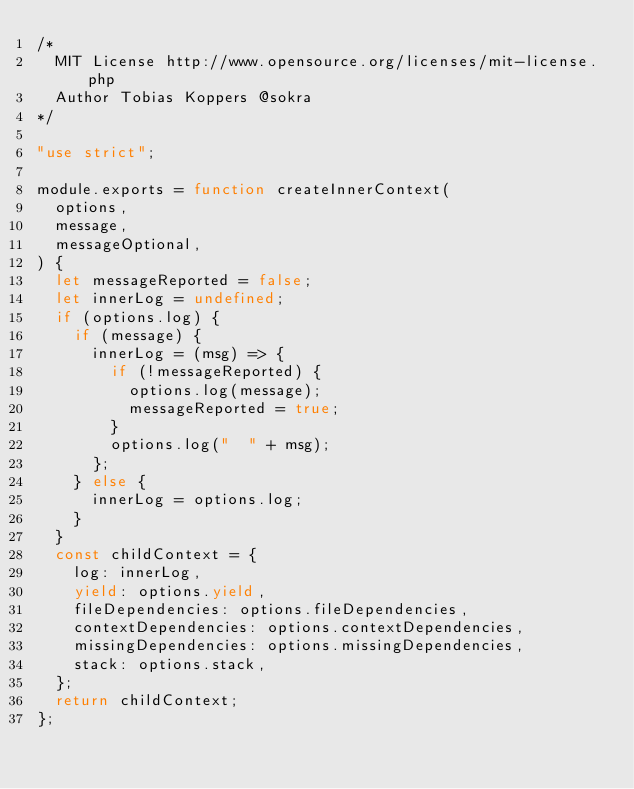Convert code to text. <code><loc_0><loc_0><loc_500><loc_500><_JavaScript_>/*
	MIT License http://www.opensource.org/licenses/mit-license.php
	Author Tobias Koppers @sokra
*/

"use strict";

module.exports = function createInnerContext(
  options,
  message,
  messageOptional,
) {
  let messageReported = false;
  let innerLog = undefined;
  if (options.log) {
    if (message) {
      innerLog = (msg) => {
        if (!messageReported) {
          options.log(message);
          messageReported = true;
        }
        options.log("  " + msg);
      };
    } else {
      innerLog = options.log;
    }
  }
  const childContext = {
    log: innerLog,
    yield: options.yield,
    fileDependencies: options.fileDependencies,
    contextDependencies: options.contextDependencies,
    missingDependencies: options.missingDependencies,
    stack: options.stack,
  };
  return childContext;
};
</code> 